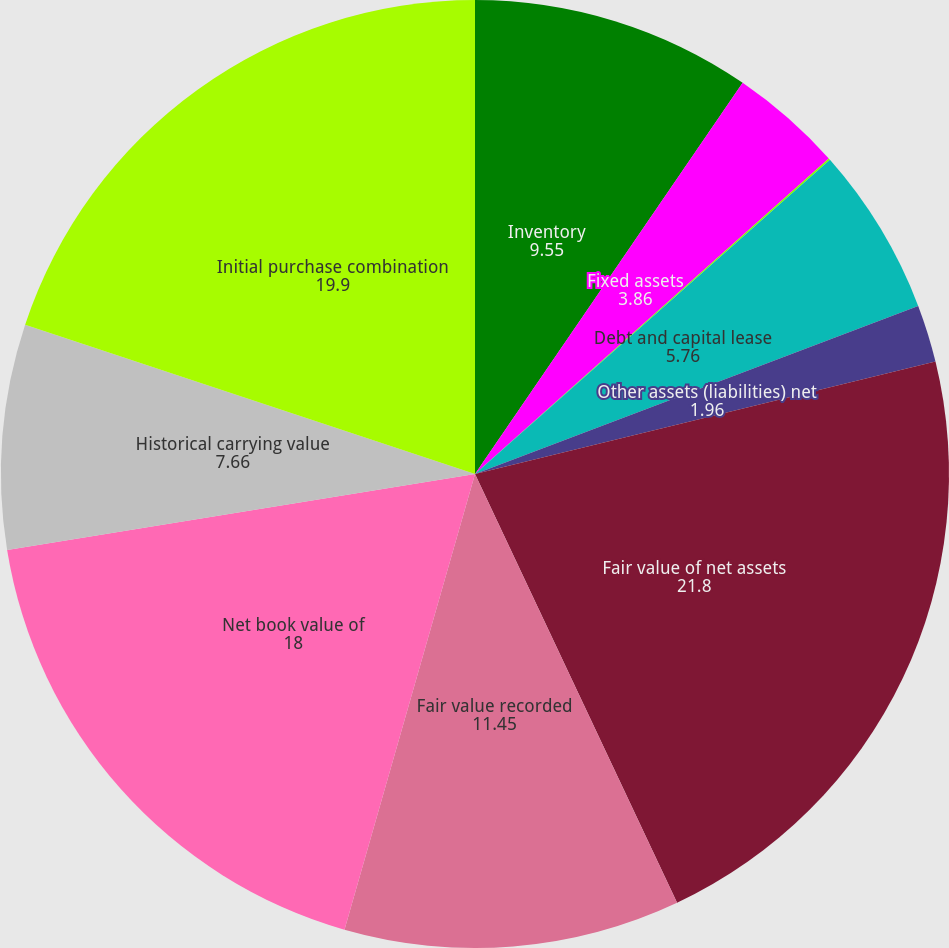<chart> <loc_0><loc_0><loc_500><loc_500><pie_chart><fcel>Inventory<fcel>Fixed assets<fcel>Intangible assets<fcel>Debt and capital lease<fcel>Other assets (liabilities) net<fcel>Fair value of net assets<fcel>Fair value recorded<fcel>Net book value of<fcel>Historical carrying value<fcel>Initial purchase combination<nl><fcel>9.55%<fcel>3.86%<fcel>0.06%<fcel>5.76%<fcel>1.96%<fcel>21.8%<fcel>11.45%<fcel>18.0%<fcel>7.66%<fcel>19.9%<nl></chart> 